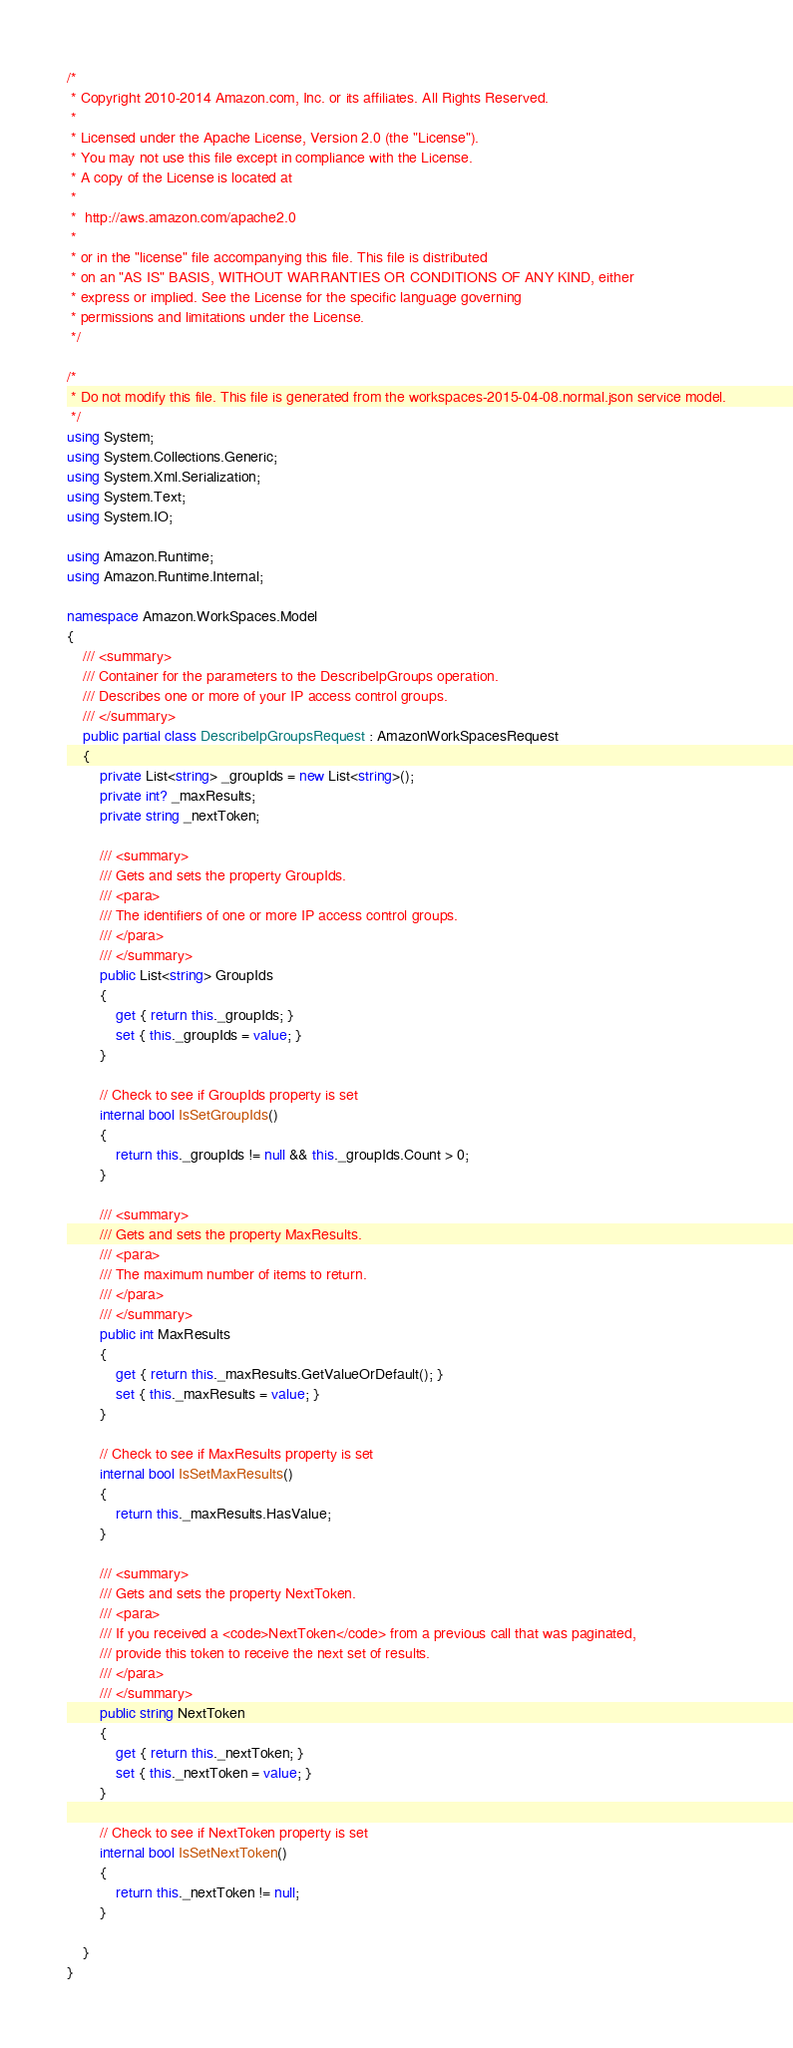<code> <loc_0><loc_0><loc_500><loc_500><_C#_>/*
 * Copyright 2010-2014 Amazon.com, Inc. or its affiliates. All Rights Reserved.
 * 
 * Licensed under the Apache License, Version 2.0 (the "License").
 * You may not use this file except in compliance with the License.
 * A copy of the License is located at
 * 
 *  http://aws.amazon.com/apache2.0
 * 
 * or in the "license" file accompanying this file. This file is distributed
 * on an "AS IS" BASIS, WITHOUT WARRANTIES OR CONDITIONS OF ANY KIND, either
 * express or implied. See the License for the specific language governing
 * permissions and limitations under the License.
 */

/*
 * Do not modify this file. This file is generated from the workspaces-2015-04-08.normal.json service model.
 */
using System;
using System.Collections.Generic;
using System.Xml.Serialization;
using System.Text;
using System.IO;

using Amazon.Runtime;
using Amazon.Runtime.Internal;

namespace Amazon.WorkSpaces.Model
{
    /// <summary>
    /// Container for the parameters to the DescribeIpGroups operation.
    /// Describes one or more of your IP access control groups.
    /// </summary>
    public partial class DescribeIpGroupsRequest : AmazonWorkSpacesRequest
    {
        private List<string> _groupIds = new List<string>();
        private int? _maxResults;
        private string _nextToken;

        /// <summary>
        /// Gets and sets the property GroupIds. 
        /// <para>
        /// The identifiers of one or more IP access control groups.
        /// </para>
        /// </summary>
        public List<string> GroupIds
        {
            get { return this._groupIds; }
            set { this._groupIds = value; }
        }

        // Check to see if GroupIds property is set
        internal bool IsSetGroupIds()
        {
            return this._groupIds != null && this._groupIds.Count > 0; 
        }

        /// <summary>
        /// Gets and sets the property MaxResults. 
        /// <para>
        /// The maximum number of items to return.
        /// </para>
        /// </summary>
        public int MaxResults
        {
            get { return this._maxResults.GetValueOrDefault(); }
            set { this._maxResults = value; }
        }

        // Check to see if MaxResults property is set
        internal bool IsSetMaxResults()
        {
            return this._maxResults.HasValue; 
        }

        /// <summary>
        /// Gets and sets the property NextToken. 
        /// <para>
        /// If you received a <code>NextToken</code> from a previous call that was paginated,
        /// provide this token to receive the next set of results.
        /// </para>
        /// </summary>
        public string NextToken
        {
            get { return this._nextToken; }
            set { this._nextToken = value; }
        }

        // Check to see if NextToken property is set
        internal bool IsSetNextToken()
        {
            return this._nextToken != null;
        }

    }
}</code> 